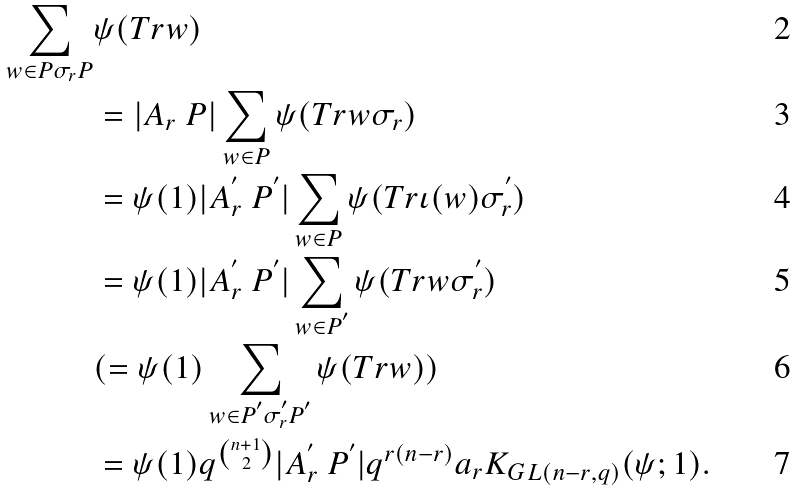Convert formula to latex. <formula><loc_0><loc_0><loc_500><loc_500>\sum _ { w \in P \sigma _ { r } P } & \psi ( T r w ) \\ & = | A _ { r } \ P | \sum _ { w \in P } \psi ( T r w \sigma _ { r } ) \\ & = \psi ( 1 ) | A _ { r } ^ { ^ { \prime } } \ P ^ { ^ { \prime } } | \sum _ { w \in P } \psi ( T r \iota ( w ) \sigma _ { r } ^ { ^ { \prime } } ) \\ & = \psi ( 1 ) | A _ { r } ^ { ^ { \prime } } \ P ^ { ^ { \prime } } | \sum _ { w \in P ^ { ^ { \prime } } } \psi ( T r w \sigma _ { r } ^ { ^ { \prime } } ) \\ & ( = \psi ( 1 ) \sum _ { w \in P ^ { ^ { \prime } } \sigma _ { r } ^ { ^ { \prime } } P ^ { ^ { \prime } } } \psi ( T r w ) ) \\ & = \psi ( 1 ) q ^ { \binom { n + 1 } { 2 } } | A _ { r } ^ { ^ { \prime } } \ P ^ { ^ { \prime } } | q ^ { r ( n - r ) } a _ { r } K _ { G L ( n - r , q ) } ( \psi ; 1 ) .</formula> 